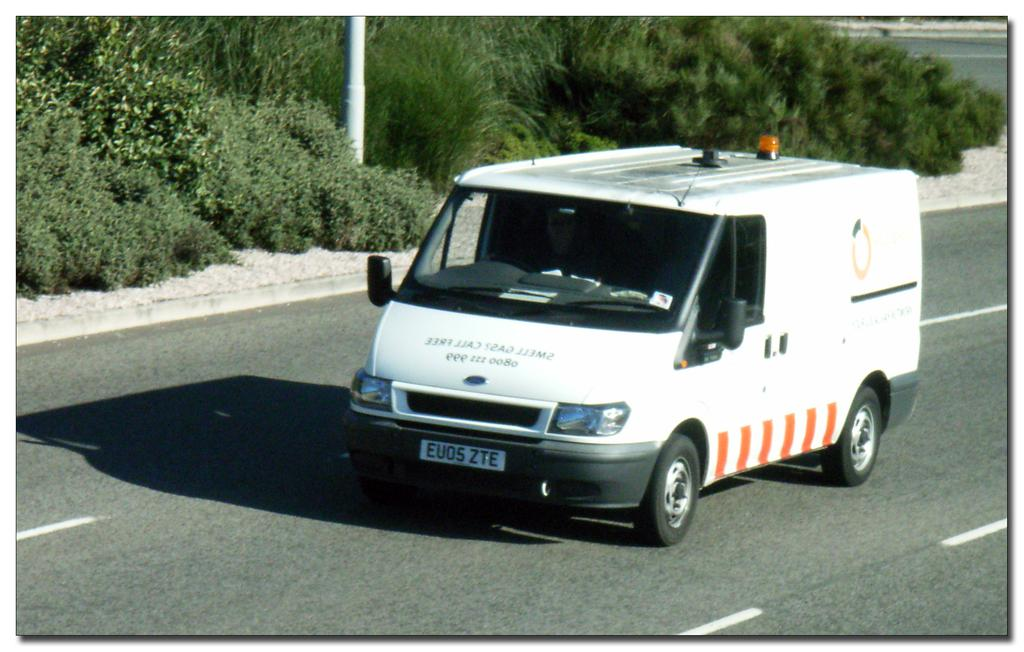<image>
Provide a brief description of the given image. A white van with the license plate EU05 ZTE is driving on a road. 